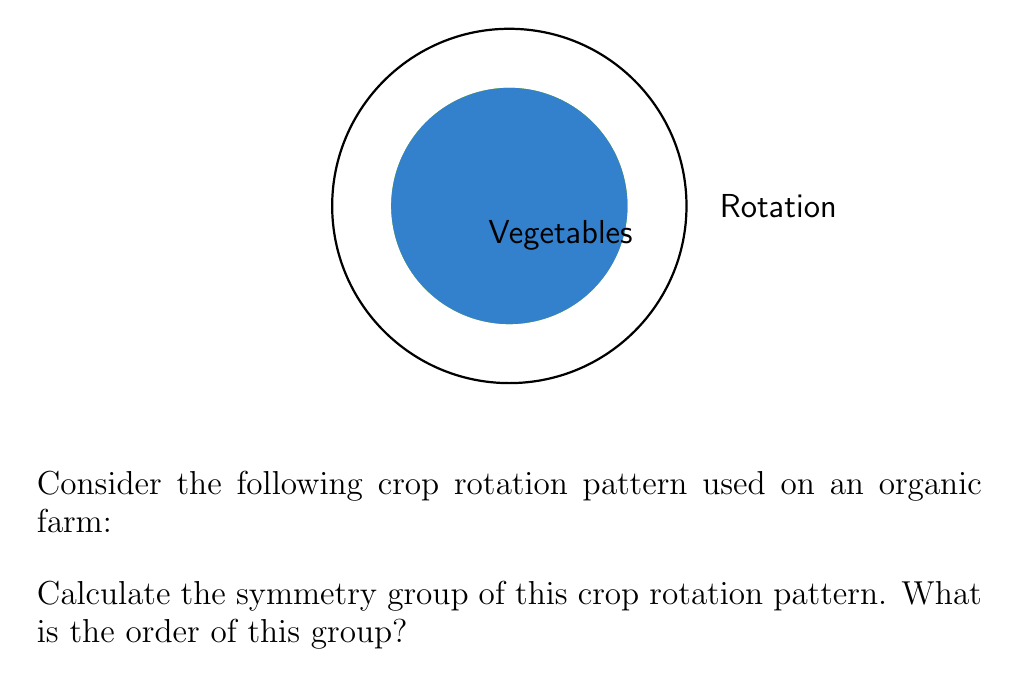Show me your answer to this math problem. To determine the symmetry group of this crop rotation pattern, we need to identify all the symmetries that preserve the arrangement of crops:

1) Rotational symmetries:
   - Identity (0° rotation)
   - 120° clockwise rotation
   - 240° clockwise rotation (equivalent to 120° counterclockwise)

2) Reflectional symmetries:
   There are no reflectional symmetries in this pattern because the crops are in a specific order.

The symmetries form a group under composition. This group is isomorphic to the cyclic group $C_3$ or $\mathbb{Z}_3$.

Properties of this group:
- It has 3 elements: $\{e, r, r^2\}$, where $e$ is the identity, $r$ is a 120° rotation, and $r^2$ is a 240° rotation.
- The group operation table:
  $$\begin{array}{c|ccc}
    \circ & e & r & r^2 \\
    \hline
    e     & e & r & r^2 \\
    r     & r & r^2 & e \\
    r^2   & r^2 & e & r
  \end{array}$$

The order of a group is the number of elements in the group. In this case, there are 3 elements, so the order of the group is 3.
Answer: $C_3$ (or $\mathbb{Z}_3$); order 3 